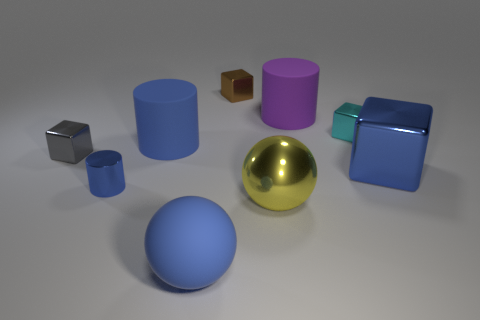There is a tiny cube that is both in front of the purple rubber thing and to the left of the small cyan cube; what color is it?
Ensure brevity in your answer.  Gray. How many other things are there of the same material as the gray cube?
Your answer should be compact. 5. Are there fewer large cubes than tiny cubes?
Your answer should be very brief. Yes. Is the large blue cube made of the same material as the ball that is left of the tiny brown object?
Give a very brief answer. No. The large metal thing that is in front of the big metallic cube has what shape?
Your answer should be very brief. Sphere. Is there anything else of the same color as the big shiny ball?
Your answer should be very brief. No. Are there fewer small brown things that are behind the purple matte thing than large purple balls?
Keep it short and to the point. No. How many blue objects are the same size as the yellow shiny ball?
Provide a succinct answer. 3. The large shiny thing that is the same color as the tiny metallic cylinder is what shape?
Your answer should be very brief. Cube. There is a small thing left of the tiny blue metallic cylinder to the left of the cylinder on the right side of the large blue rubber cylinder; what shape is it?
Offer a very short reply. Cube. 